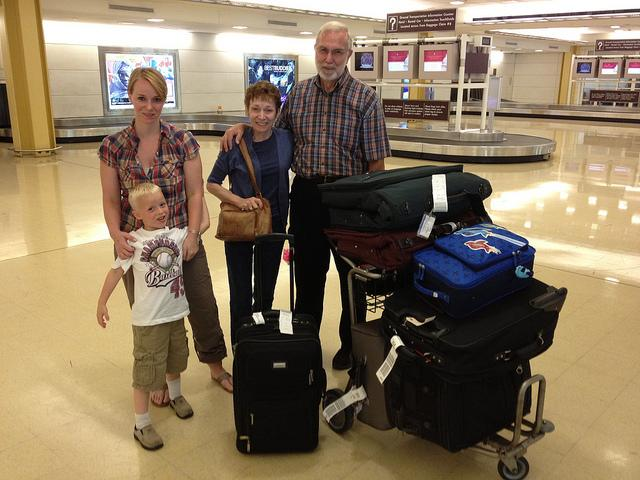What is this area for?

Choices:
A) claiming baggage
B) boarding flight
C) waiting
D) security claiming baggage 